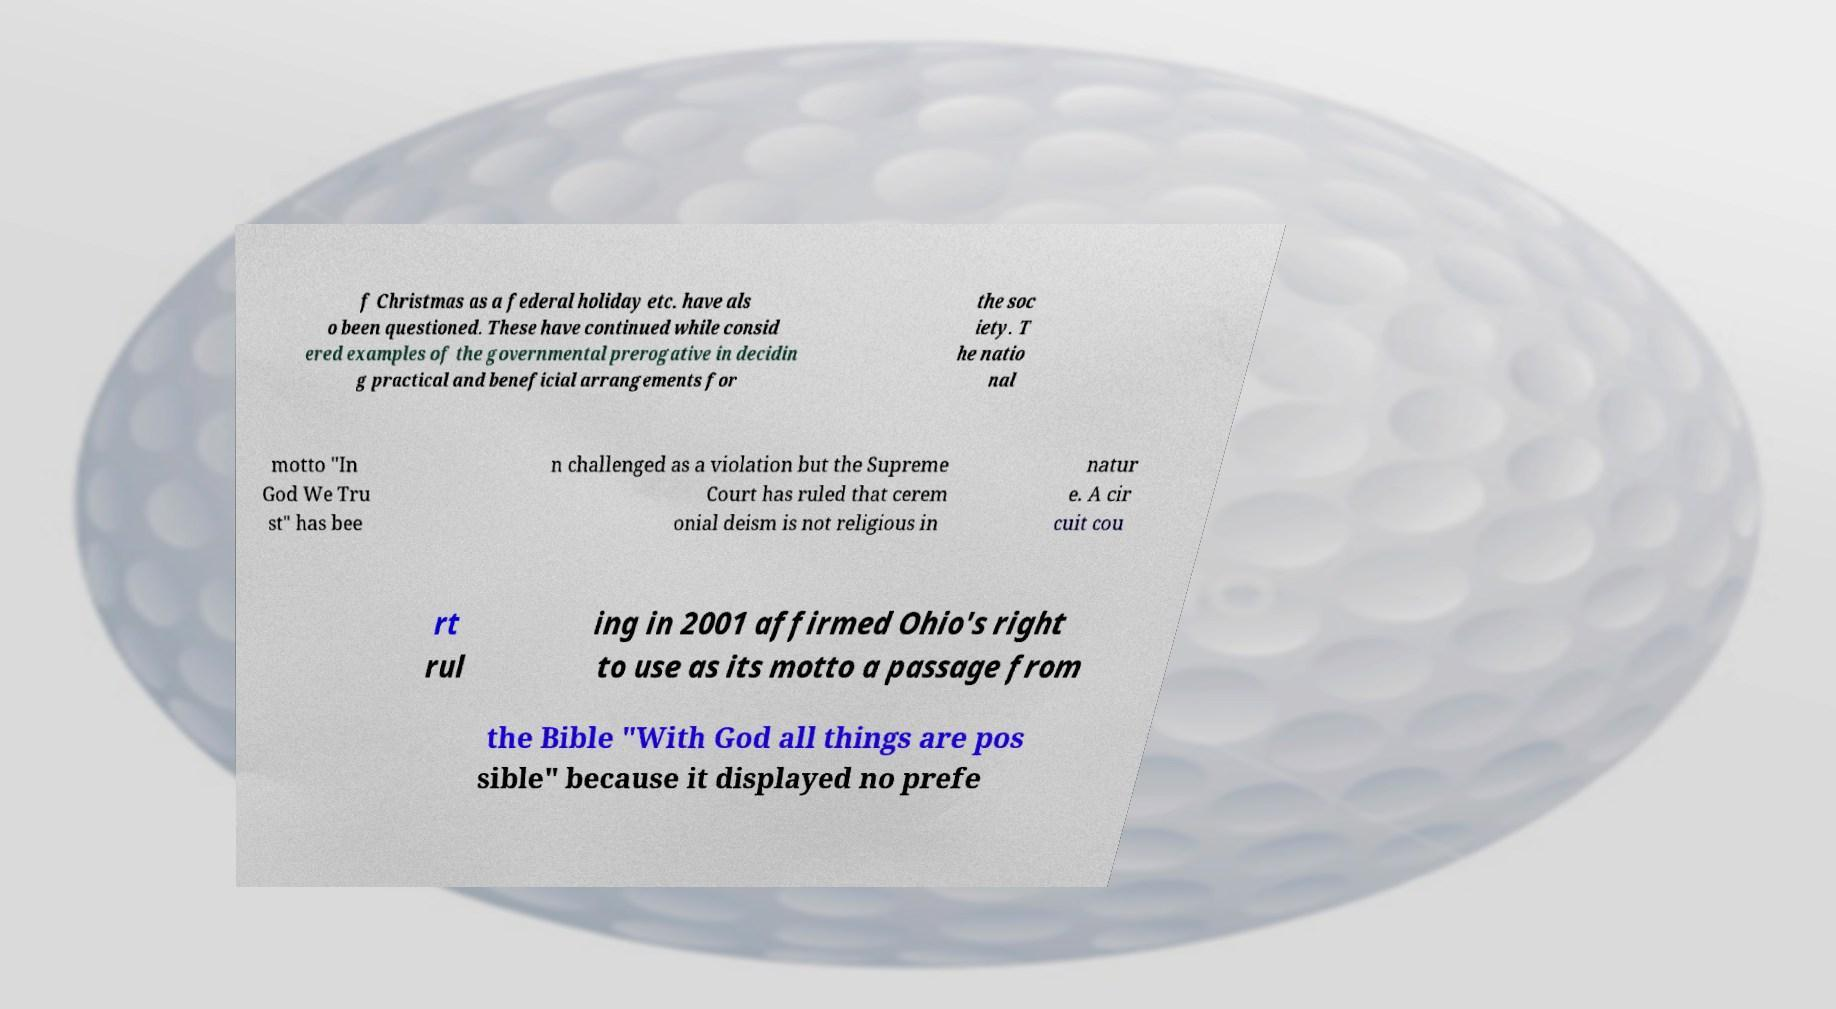I need the written content from this picture converted into text. Can you do that? f Christmas as a federal holiday etc. have als o been questioned. These have continued while consid ered examples of the governmental prerogative in decidin g practical and beneficial arrangements for the soc iety. T he natio nal motto "In God We Tru st" has bee n challenged as a violation but the Supreme Court has ruled that cerem onial deism is not religious in natur e. A cir cuit cou rt rul ing in 2001 affirmed Ohio's right to use as its motto a passage from the Bible "With God all things are pos sible" because it displayed no prefe 